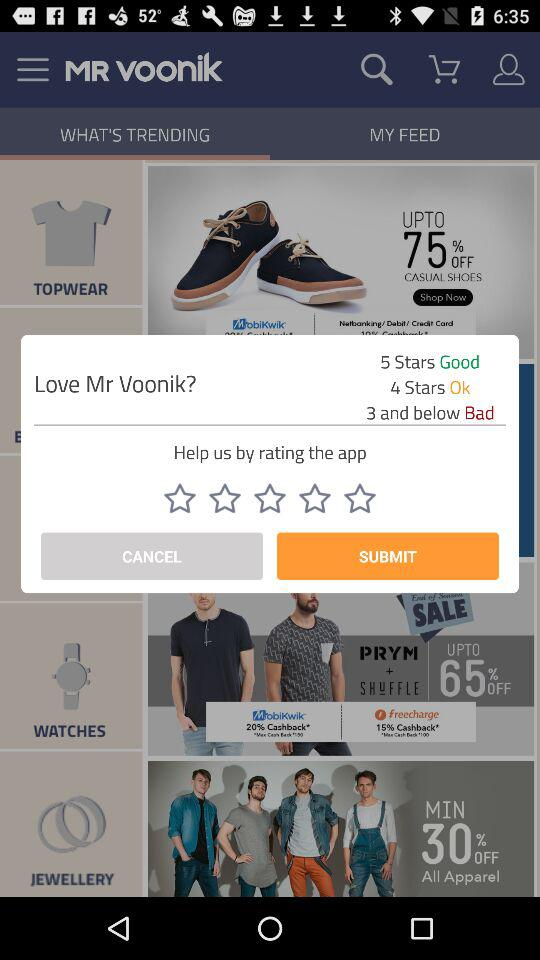What is the rating for good? The rating for good is 5 stars. 